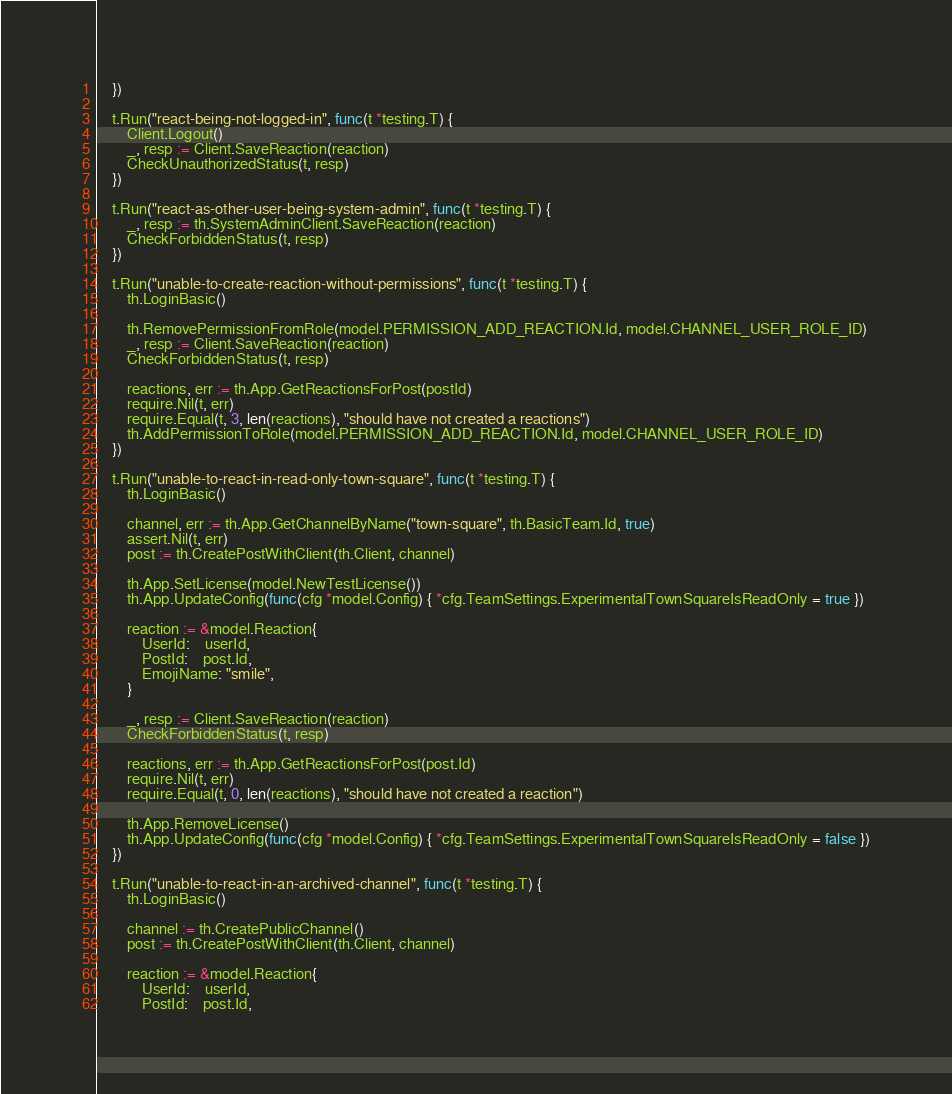<code> <loc_0><loc_0><loc_500><loc_500><_Go_>	})

	t.Run("react-being-not-logged-in", func(t *testing.T) {
		Client.Logout()
		_, resp := Client.SaveReaction(reaction)
		CheckUnauthorizedStatus(t, resp)
	})

	t.Run("react-as-other-user-being-system-admin", func(t *testing.T) {
		_, resp := th.SystemAdminClient.SaveReaction(reaction)
		CheckForbiddenStatus(t, resp)
	})

	t.Run("unable-to-create-reaction-without-permissions", func(t *testing.T) {
		th.LoginBasic()

		th.RemovePermissionFromRole(model.PERMISSION_ADD_REACTION.Id, model.CHANNEL_USER_ROLE_ID)
		_, resp := Client.SaveReaction(reaction)
		CheckForbiddenStatus(t, resp)

		reactions, err := th.App.GetReactionsForPost(postId)
		require.Nil(t, err)
		require.Equal(t, 3, len(reactions), "should have not created a reactions")
		th.AddPermissionToRole(model.PERMISSION_ADD_REACTION.Id, model.CHANNEL_USER_ROLE_ID)
	})

	t.Run("unable-to-react-in-read-only-town-square", func(t *testing.T) {
		th.LoginBasic()

		channel, err := th.App.GetChannelByName("town-square", th.BasicTeam.Id, true)
		assert.Nil(t, err)
		post := th.CreatePostWithClient(th.Client, channel)

		th.App.SetLicense(model.NewTestLicense())
		th.App.UpdateConfig(func(cfg *model.Config) { *cfg.TeamSettings.ExperimentalTownSquareIsReadOnly = true })

		reaction := &model.Reaction{
			UserId:    userId,
			PostId:    post.Id,
			EmojiName: "smile",
		}

		_, resp := Client.SaveReaction(reaction)
		CheckForbiddenStatus(t, resp)

		reactions, err := th.App.GetReactionsForPost(post.Id)
		require.Nil(t, err)
		require.Equal(t, 0, len(reactions), "should have not created a reaction")

		th.App.RemoveLicense()
		th.App.UpdateConfig(func(cfg *model.Config) { *cfg.TeamSettings.ExperimentalTownSquareIsReadOnly = false })
	})

	t.Run("unable-to-react-in-an-archived-channel", func(t *testing.T) {
		th.LoginBasic()

		channel := th.CreatePublicChannel()
		post := th.CreatePostWithClient(th.Client, channel)

		reaction := &model.Reaction{
			UserId:    userId,
			PostId:    post.Id,</code> 